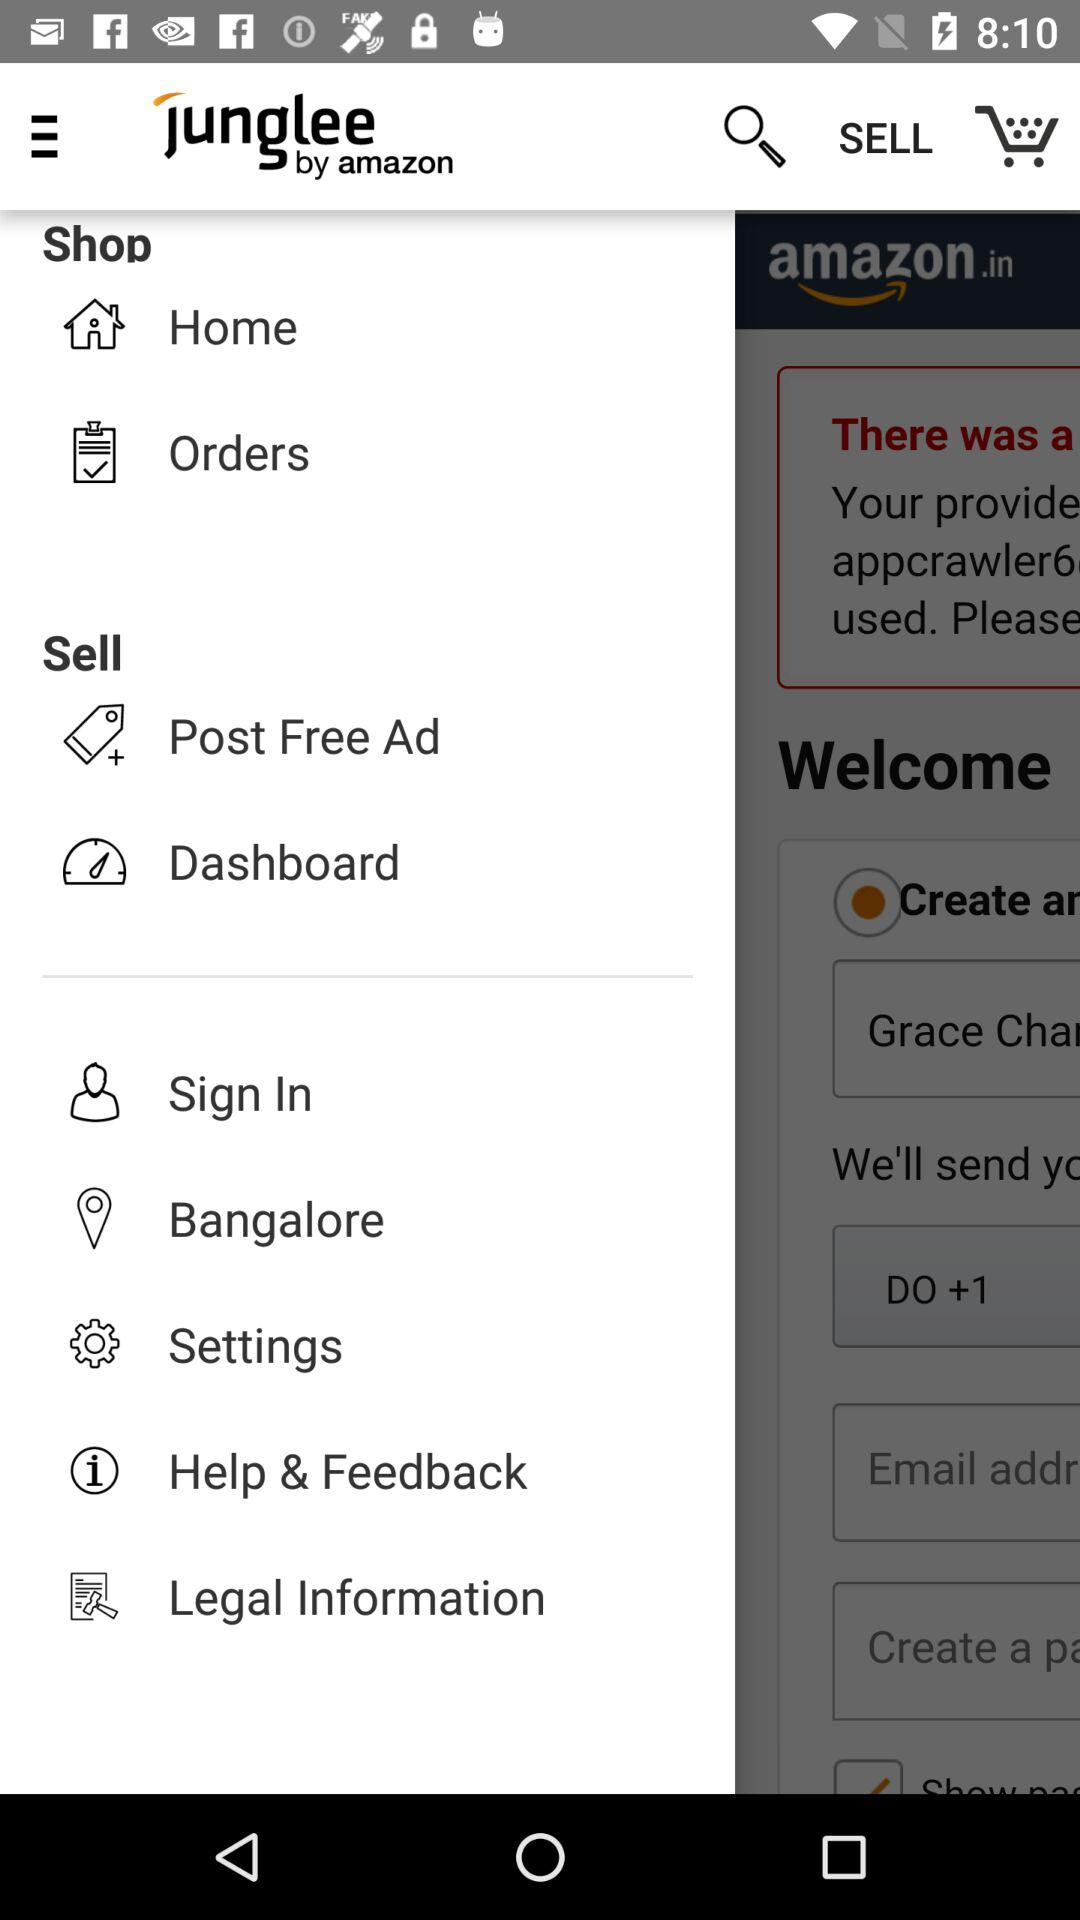What is the mentioned location? The mentioned location is Bangalore. 